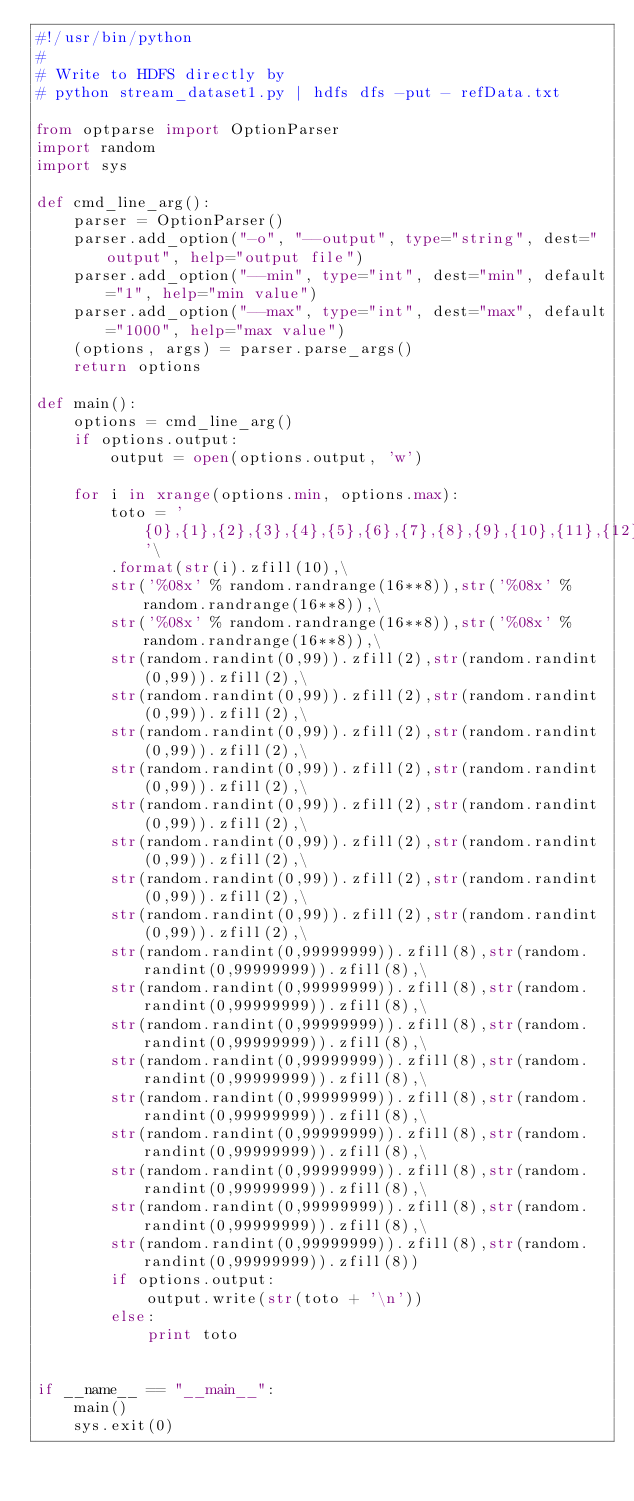<code> <loc_0><loc_0><loc_500><loc_500><_Python_>#!/usr/bin/python
#
# Write to HDFS directly by 
# python stream_dataset1.py | hdfs dfs -put - refData.txt

from optparse import OptionParser
import random
import sys

def cmd_line_arg():
	parser = OptionParser()
	parser.add_option("-o", "--output", type="string", dest="output", help="output file")
	parser.add_option("--min", type="int", dest="min", default="1", help="min value")
	parser.add_option("--max", type="int", dest="max", default="1000", help="max value")
	(options, args) = parser.parse_args()
	return options

def main():
	options = cmd_line_arg()
	if options.output:
		output = open(options.output, 'w')

	for i in xrange(options.min, options.max):		
		toto = '{0},{1},{2},{3},{4},{5},{6},{7},{8},{9},{10},{11},{12},{13},{14},{15},{16},{17},{18},{19},{20},{21},{22},{23},{24},{25},{26},{27},{28},{29},{30},{31},{32},{33},{34},{35}'\
		.format(str(i).zfill(10),\
		str('%08x' % random.randrange(16**8)),str('%08x' % random.randrange(16**8)),\
		str('%08x' % random.randrange(16**8)),str('%08x' % random.randrange(16**8)),\
		str(random.randint(0,99)).zfill(2),str(random.randint(0,99)).zfill(2),\
		str(random.randint(0,99)).zfill(2),str(random.randint(0,99)).zfill(2),\
		str(random.randint(0,99)).zfill(2),str(random.randint(0,99)).zfill(2),\
		str(random.randint(0,99)).zfill(2),str(random.randint(0,99)).zfill(2),\
		str(random.randint(0,99)).zfill(2),str(random.randint(0,99)).zfill(2),\
		str(random.randint(0,99)).zfill(2),str(random.randint(0,99)).zfill(2),\
		str(random.randint(0,99)).zfill(2),str(random.randint(0,99)).zfill(2),\
		str(random.randint(0,99)).zfill(2),str(random.randint(0,99)).zfill(2),\
		str(random.randint(0,99999999)).zfill(8),str(random.randint(0,99999999)).zfill(8),\
		str(random.randint(0,99999999)).zfill(8),str(random.randint(0,99999999)).zfill(8),\
		str(random.randint(0,99999999)).zfill(8),str(random.randint(0,99999999)).zfill(8),\
		str(random.randint(0,99999999)).zfill(8),str(random.randint(0,99999999)).zfill(8),\
		str(random.randint(0,99999999)).zfill(8),str(random.randint(0,99999999)).zfill(8),\
		str(random.randint(0,99999999)).zfill(8),str(random.randint(0,99999999)).zfill(8),\
		str(random.randint(0,99999999)).zfill(8),str(random.randint(0,99999999)).zfill(8),\
		str(random.randint(0,99999999)).zfill(8),str(random.randint(0,99999999)).zfill(8),\
		str(random.randint(0,99999999)).zfill(8),str(random.randint(0,99999999)).zfill(8))
		if options.output:
			output.write(str(toto + '\n'))
		else:
			print toto
	

if __name__ == "__main__":
	main()
	sys.exit(0)</code> 